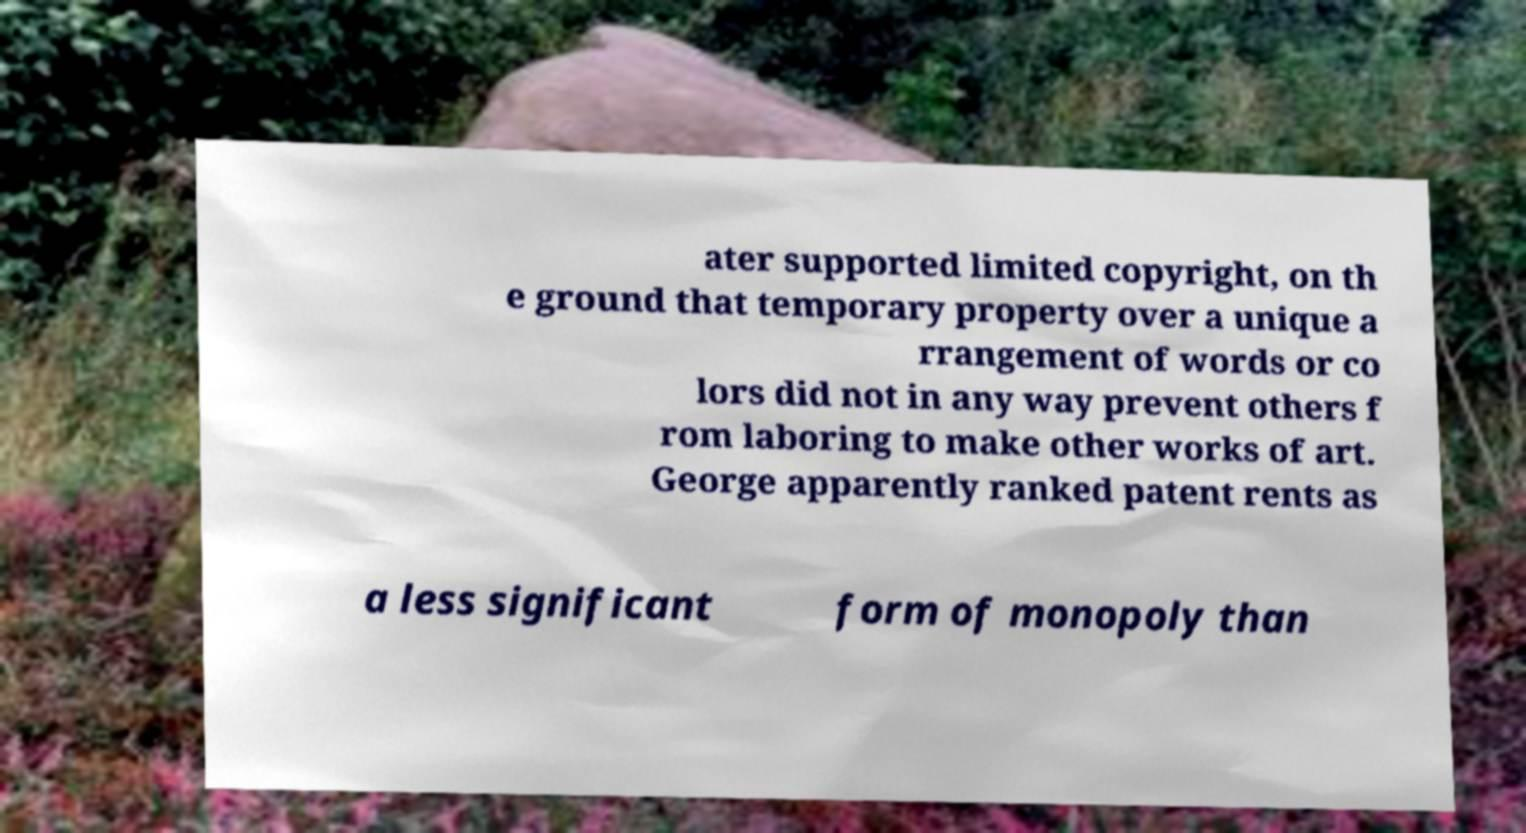For documentation purposes, I need the text within this image transcribed. Could you provide that? ater supported limited copyright, on th e ground that temporary property over a unique a rrangement of words or co lors did not in any way prevent others f rom laboring to make other works of art. George apparently ranked patent rents as a less significant form of monopoly than 